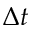Convert formula to latex. <formula><loc_0><loc_0><loc_500><loc_500>\Delta { t }</formula> 